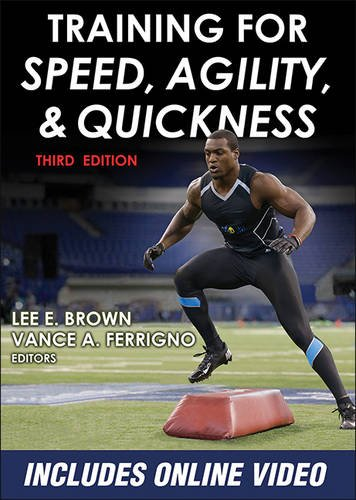What are the main topics covered in this book? The main topics covered in the book include various exercises and drills to improve speed, agility, and quickness, alongside strategies for their effective implementation in training routines. Can the techniques in this book be applied to all sports? Yes, the techniques in this book are versatile and can be adapted for a wide range of sports that benefit from enhanced speed, agility, and quickness. 